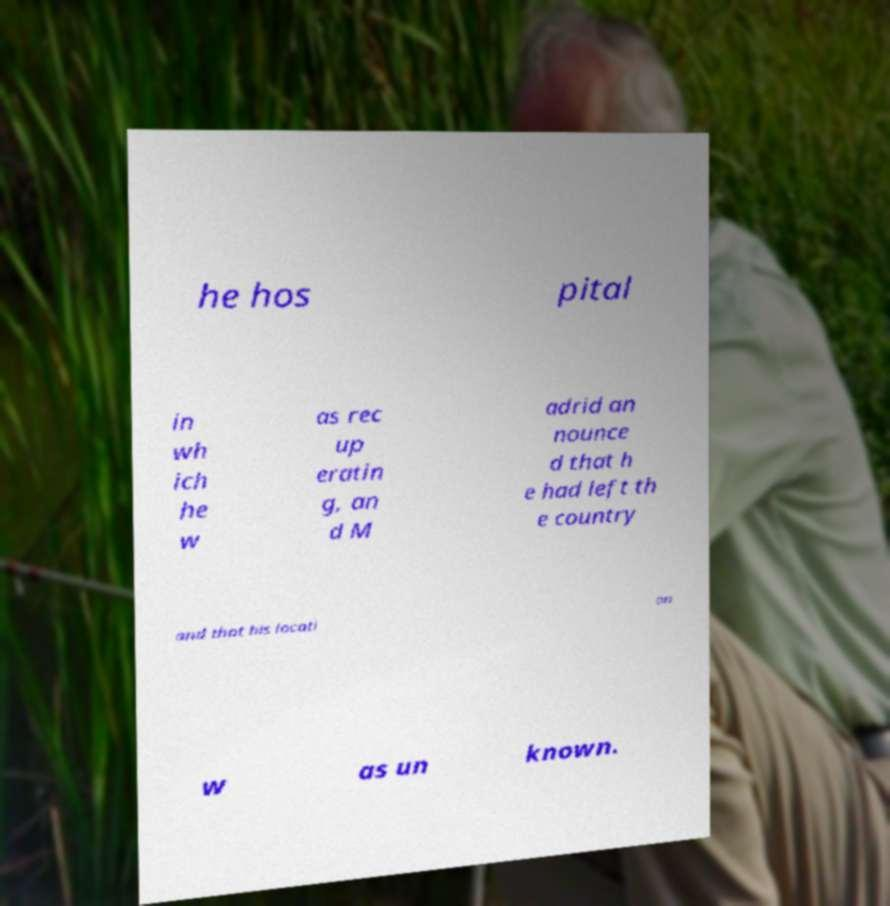Please read and relay the text visible in this image. What does it say? he hos pital in wh ich he w as rec up eratin g, an d M adrid an nounce d that h e had left th e country and that his locati on w as un known. 